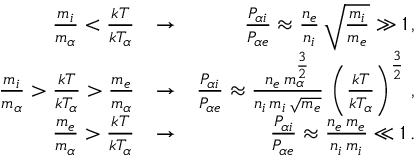<formula> <loc_0><loc_0><loc_500><loc_500>\begin{array} { r l r } { \frac { m _ { i } } { m _ { \alpha } } < \frac { k T } { k T _ { \alpha } } } & { \rightarrow } & { \frac { P _ { \alpha i } } { P _ { \alpha e } } \approx \frac { n _ { e } } { n _ { i } } \, \sqrt { \frac { m _ { i } } { m _ { e } } } \gg 1 \, , } \\ { \frac { m _ { i } } { m _ { \alpha } } > \frac { k T } { k T _ { \alpha } } > \frac { m _ { e } } { m _ { \alpha } } } & { \rightarrow } & { \frac { P _ { \alpha i } } { P _ { \alpha e } } \approx \frac { n _ { e } \, m _ { \alpha } ^ { \frac { 3 } { 2 } } } { n _ { i } \, m _ { i } \, \sqrt { m _ { e } } } \, \left ( \frac { k T } { k T _ { \alpha } } \right ) ^ { \frac { 3 } { 2 } } \, , } \\ { \frac { m _ { e } } { m _ { \alpha } } > \frac { k T } { k T _ { \alpha } } } & { \rightarrow } & { \frac { P _ { \alpha i } } { P _ { \alpha e } } \approx \frac { n _ { e } \, m _ { e } } { n _ { i } \, m _ { i } } \ll 1 \, . } \end{array}</formula> 